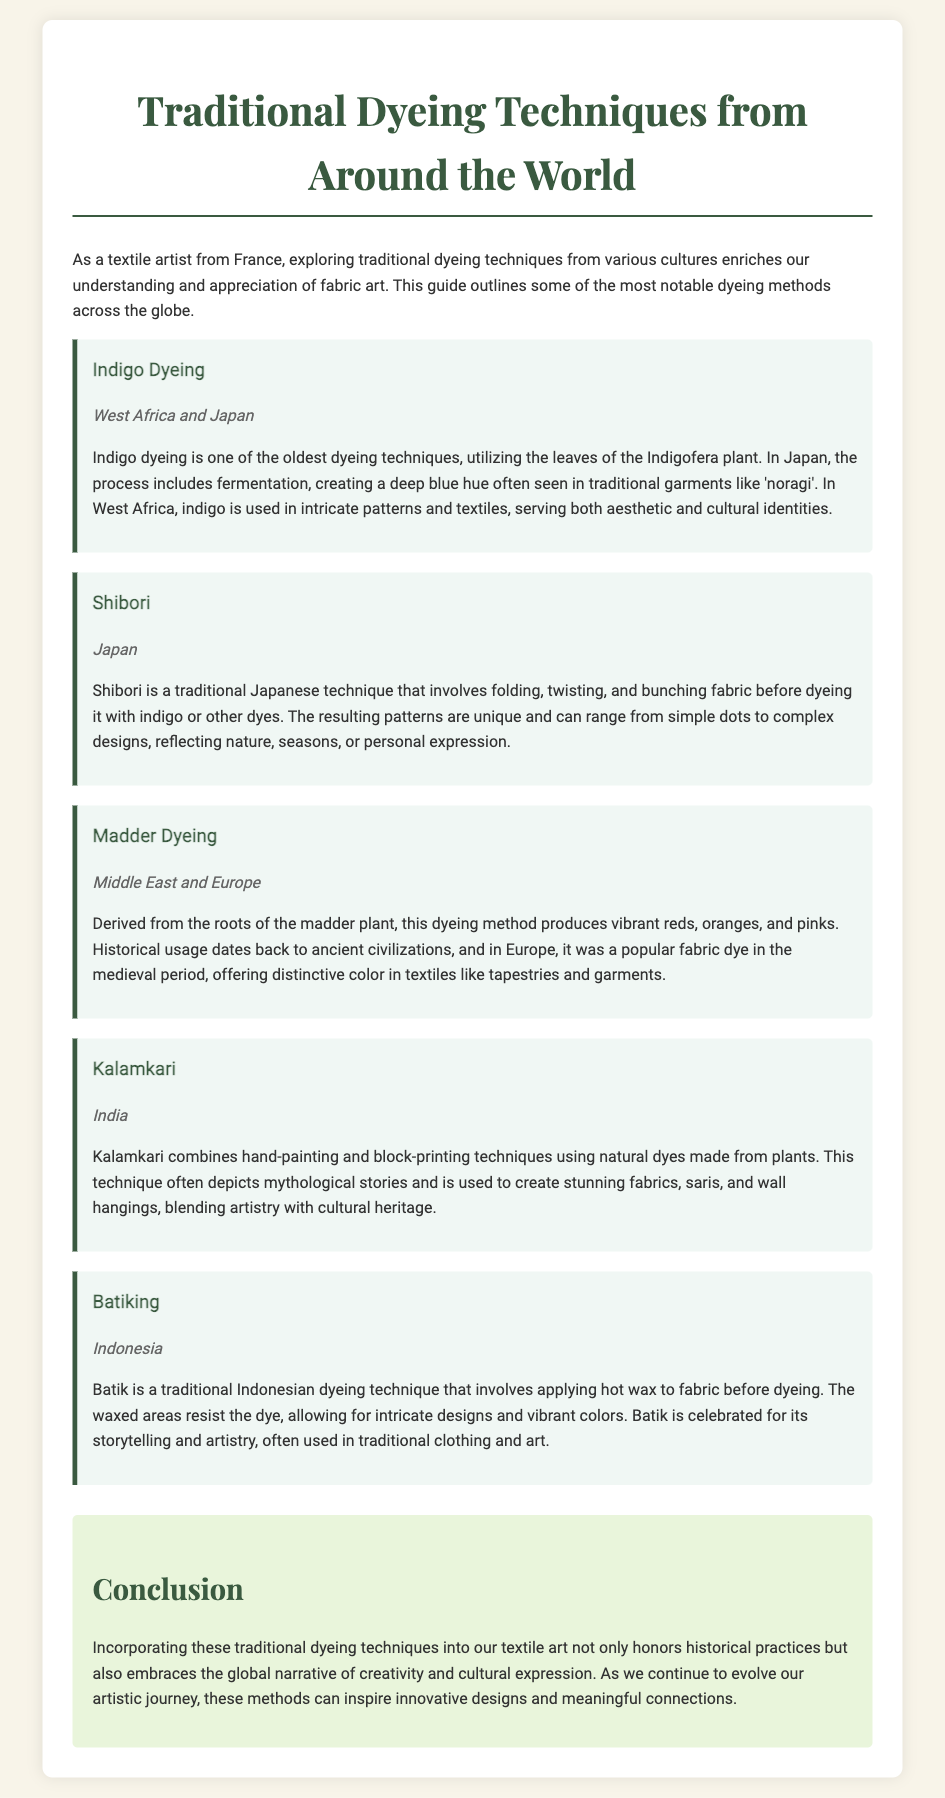What is the first dyeing technique mentioned? The first dyeing technique listed in the document is Indigo Dyeing.
Answer: Indigo Dyeing In which region is Shibori practiced? Shibori is specifically mentioned as a traditional technique from Japan.
Answer: Japan What plant is used in Madder Dyeing? The Madder Dyeing technique derives its dye from the roots of the madder plant.
Answer: Madder plant What colors are produced by Madder Dyeing? Madder Dyeing produces vibrant reds, oranges, and pinks.
Answer: Reds, oranges, and pinks What artistic element does Kalamkari often depict? Kalamkari techniques often depict mythological stories.
Answer: Mythological stories How is Batiking different from other dyeing techniques? Batiking involves applying hot wax to fabric before dyeing, which is unique compared to other methods.
Answer: Applying hot wax What common feature do these dyeing techniques share? All the techniques highlighted incorporate traditional cultural practices in their methods.
Answer: Traditional cultural practices What type of conclusion is drawn about traditional dyeing techniques? The conclusion emphasizes that incorporating traditional techniques honors historical practices and inspires creativity.
Answer: Honors historical practices and inspires creativity Which country is associated with the Batik technique? The Batik technique is traditionally associated with Indonesia.
Answer: Indonesia 